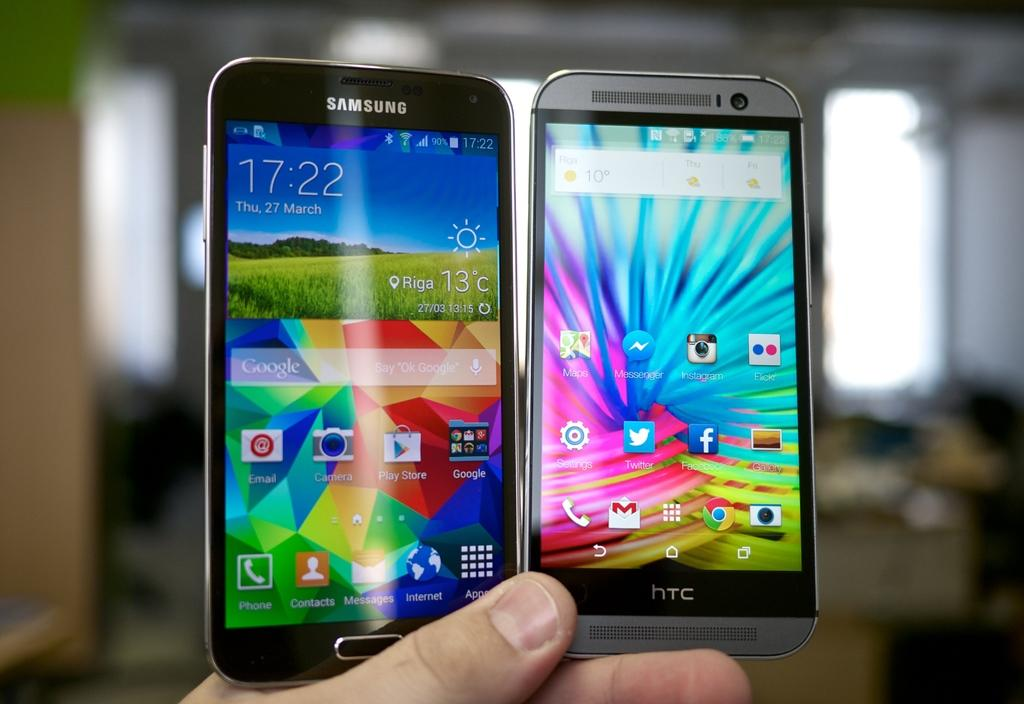Provide a one-sentence caption for the provided image. a black Samsung cell phone and silver HTC cell phone held in a hand. 